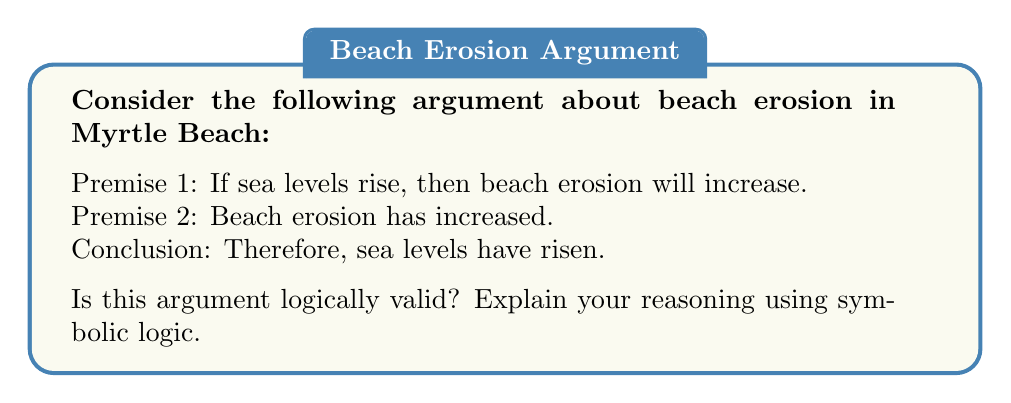Could you help me with this problem? Let's approach this step-by-step using symbolic logic:

1. Define our symbols:
   $p$: Sea levels rise
   $q$: Beach erosion increases

2. Translate the premises and conclusion:
   Premise 1: $p \rightarrow q$ (If $p$, then $q$)
   Premise 2: $q$ (Beach erosion has increased)
   Conclusion: $p$ (Therefore, sea levels have risen)

3. The argument structure is:
   $$
   \begin{align}
   p &\rightarrow q \\
   q &\\
   \therefore p &
   \end{align}
   $$

4. This argument form is known as the fallacy of affirming the consequent. It's not logically valid because it doesn't follow the rules of valid inference.

5. To be valid, we would need to affirm the antecedent ($p$) to conclude the consequent ($q$), or deny the consequent ($\neg q$) to conclude the negation of the antecedent ($\neg p$).

6. In this case, affirming $q$ doesn't necessarily mean $p$ is true. There could be other causes for increased beach erosion (e.g., changes in ocean currents, increased storm activity).

7. A valid argument would be:
   $$
   \begin{align}
   p &\rightarrow q \\
   p &\\
   \therefore q &
   \end{align}
   $$
   (Modus Ponens)

   Or:
   $$
   \begin{align}
   p &\rightarrow q \\
   \neg q &\\
   \therefore \neg p &
   \end{align}
   $$
   (Modus Tollens)

Therefore, the given argument is not logically valid, despite its premises being potentially true for Myrtle Beach.
Answer: Not valid; affirming the consequent fallacy 